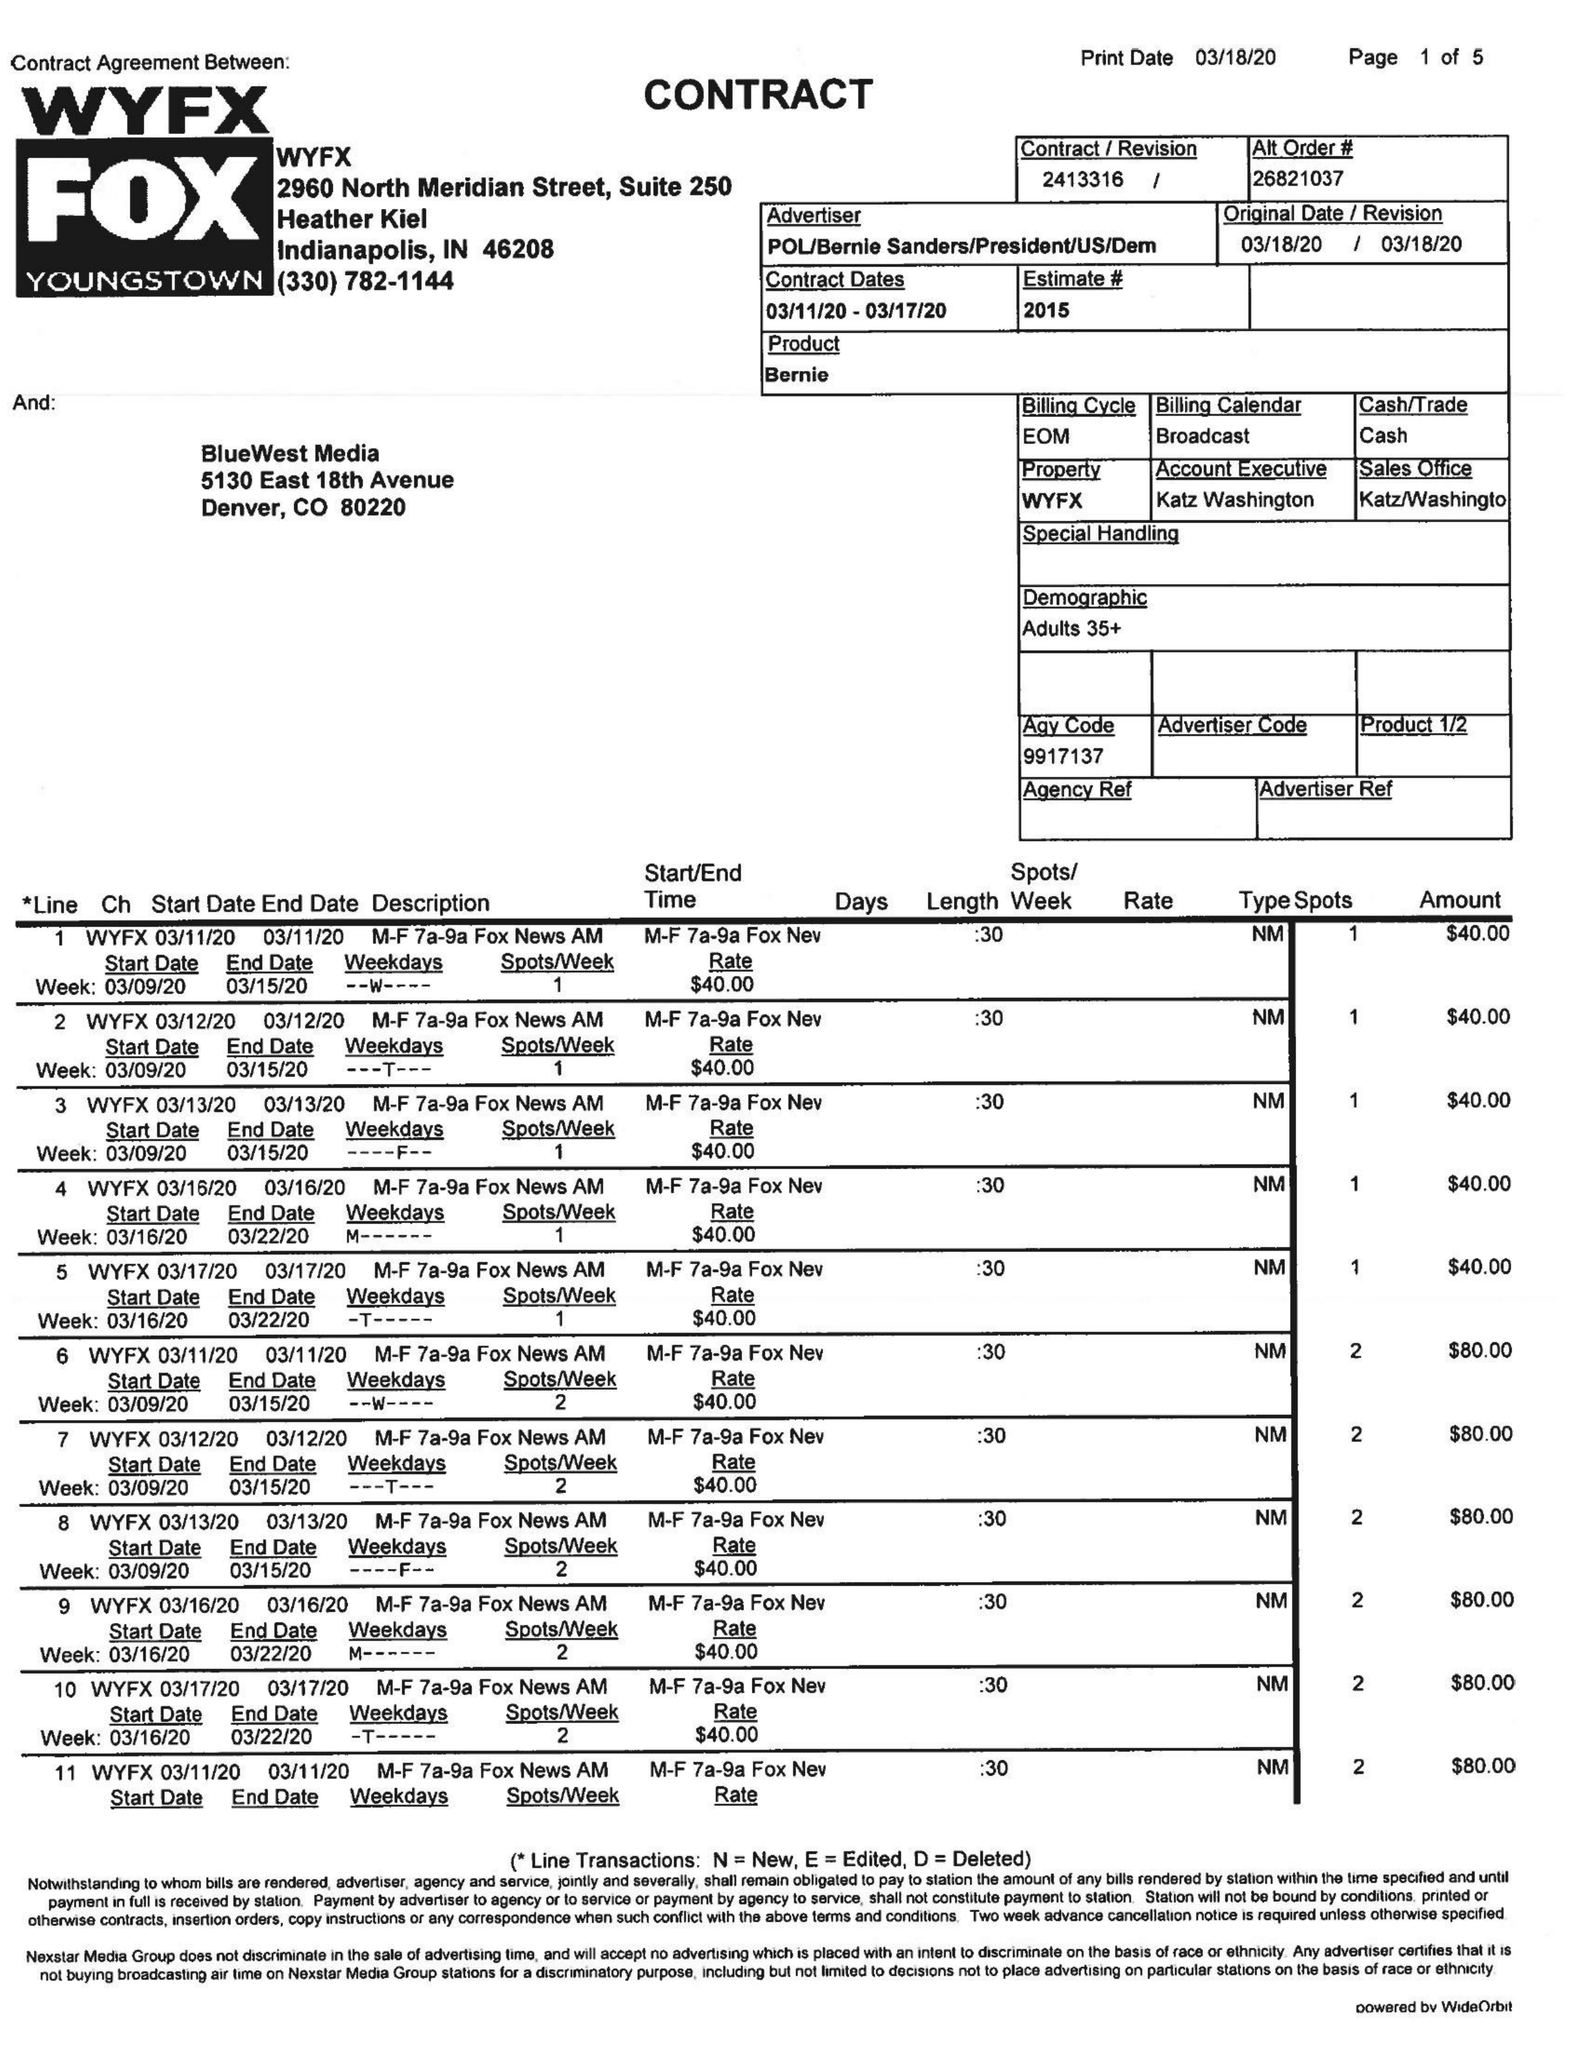What is the value for the flight_to?
Answer the question using a single word or phrase. 03/17/20 